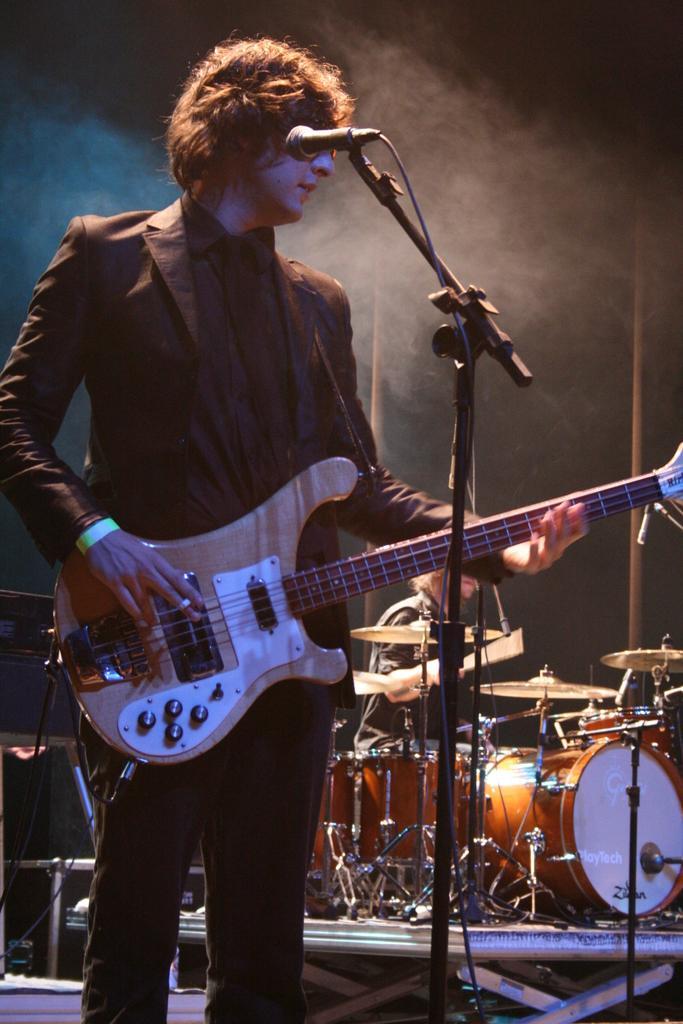Describe this image in one or two sentences. In this picture we can see a man who is holding a guitar with his hand. He is in black suit. And this is mike. On the background we can see some musical instruments. 